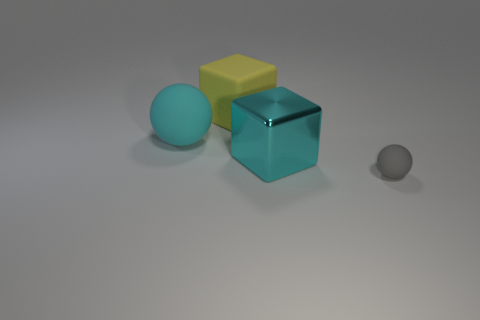Add 4 matte balls. How many objects exist? 8 Add 2 big blue cubes. How many big blue cubes exist? 2 Subtract all cyan spheres. How many spheres are left? 1 Subtract 0 red cylinders. How many objects are left? 4 Subtract 1 blocks. How many blocks are left? 1 Subtract all red blocks. Subtract all blue cylinders. How many blocks are left? 2 Subtract all yellow cylinders. How many yellow spheres are left? 0 Subtract all large cyan objects. Subtract all gray matte balls. How many objects are left? 1 Add 3 large yellow blocks. How many large yellow blocks are left? 4 